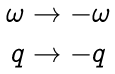<formula> <loc_0><loc_0><loc_500><loc_500>\begin{matrix} & \omega \to - \omega \\ & q \to - q \\ \end{matrix}</formula> 